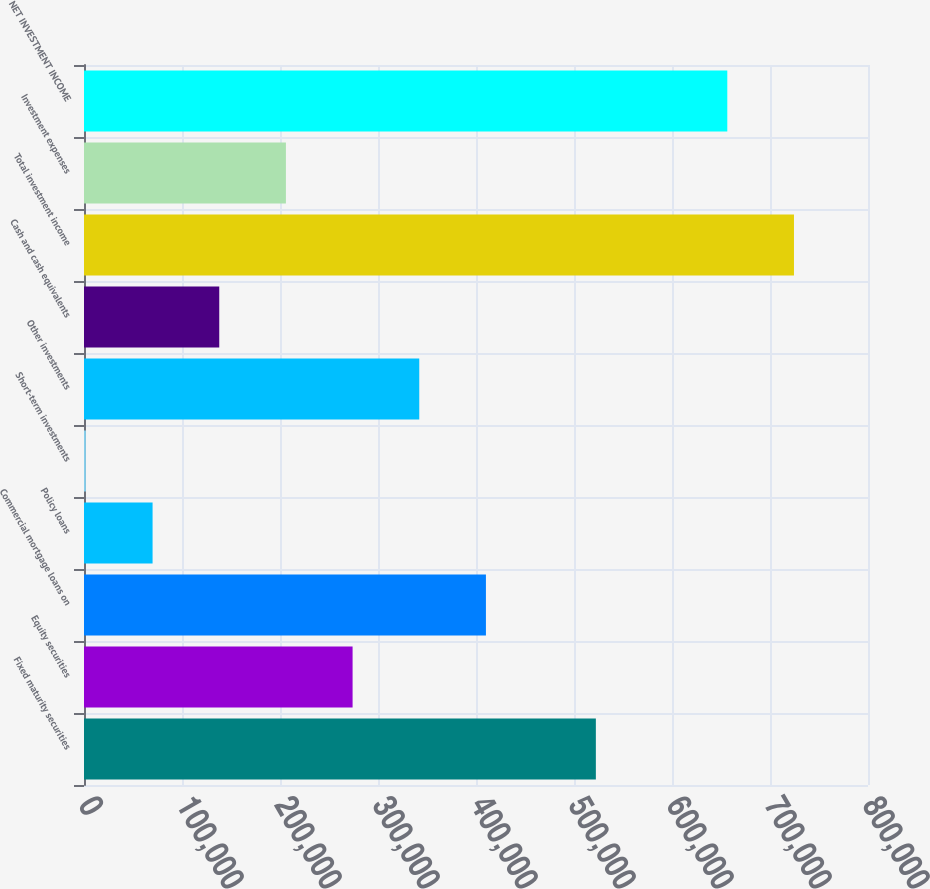<chart> <loc_0><loc_0><loc_500><loc_500><bar_chart><fcel>Fixed maturity securities<fcel>Equity securities<fcel>Commercial mortgage loans on<fcel>Policy loans<fcel>Short-term investments<fcel>Other investments<fcel>Cash and cash equivalents<fcel>Total investment income<fcel>Investment expenses<fcel>NET INVESTMENT INCOME<nl><fcel>522309<fcel>274072<fcel>410132<fcel>69980.4<fcel>1950<fcel>342102<fcel>138011<fcel>724459<fcel>206041<fcel>656429<nl></chart> 